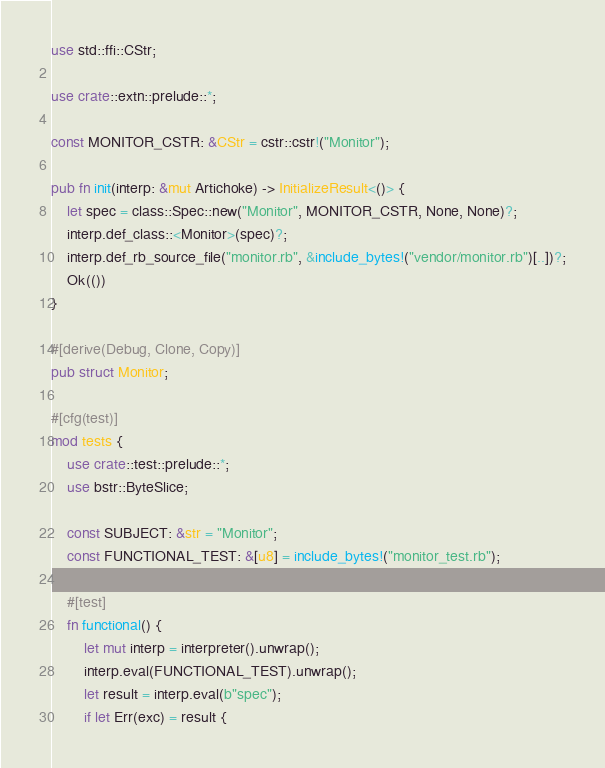<code> <loc_0><loc_0><loc_500><loc_500><_Rust_>use std::ffi::CStr;

use crate::extn::prelude::*;

const MONITOR_CSTR: &CStr = cstr::cstr!("Monitor");

pub fn init(interp: &mut Artichoke) -> InitializeResult<()> {
    let spec = class::Spec::new("Monitor", MONITOR_CSTR, None, None)?;
    interp.def_class::<Monitor>(spec)?;
    interp.def_rb_source_file("monitor.rb", &include_bytes!("vendor/monitor.rb")[..])?;
    Ok(())
}

#[derive(Debug, Clone, Copy)]
pub struct Monitor;

#[cfg(test)]
mod tests {
    use crate::test::prelude::*;
    use bstr::ByteSlice;

    const SUBJECT: &str = "Monitor";
    const FUNCTIONAL_TEST: &[u8] = include_bytes!("monitor_test.rb");

    #[test]
    fn functional() {
        let mut interp = interpreter().unwrap();
        interp.eval(FUNCTIONAL_TEST).unwrap();
        let result = interp.eval(b"spec");
        if let Err(exc) = result {</code> 